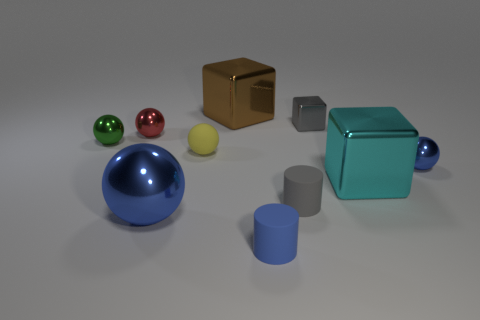Subtract all green spheres. How many spheres are left? 4 Subtract all gray blocks. How many blocks are left? 2 Subtract all blocks. How many objects are left? 7 Subtract all green balls. How many green cylinders are left? 0 Add 4 metallic balls. How many metallic balls exist? 8 Subtract 1 brown cubes. How many objects are left? 9 Subtract 2 cylinders. How many cylinders are left? 0 Subtract all yellow spheres. Subtract all purple blocks. How many spheres are left? 4 Subtract all gray blocks. Subtract all tiny gray objects. How many objects are left? 7 Add 8 small blue matte objects. How many small blue matte objects are left? 9 